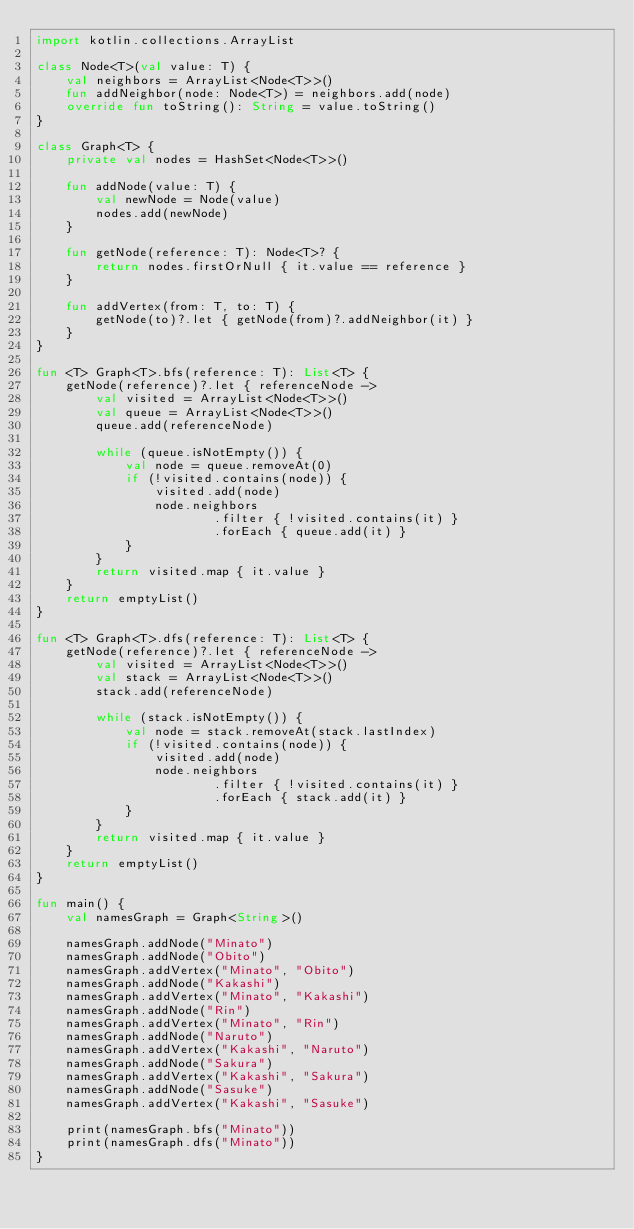<code> <loc_0><loc_0><loc_500><loc_500><_Kotlin_>import kotlin.collections.ArrayList

class Node<T>(val value: T) {
    val neighbors = ArrayList<Node<T>>()
    fun addNeighbor(node: Node<T>) = neighbors.add(node)
    override fun toString(): String = value.toString()
}

class Graph<T> {
    private val nodes = HashSet<Node<T>>()

    fun addNode(value: T) {
        val newNode = Node(value)
        nodes.add(newNode)
    }

    fun getNode(reference: T): Node<T>? {
        return nodes.firstOrNull { it.value == reference }
    }

    fun addVertex(from: T, to: T) {
        getNode(to)?.let { getNode(from)?.addNeighbor(it) }
    }
}

fun <T> Graph<T>.bfs(reference: T): List<T> {
    getNode(reference)?.let { referenceNode ->
        val visited = ArrayList<Node<T>>()
        val queue = ArrayList<Node<T>>()
        queue.add(referenceNode)

        while (queue.isNotEmpty()) {
            val node = queue.removeAt(0)
            if (!visited.contains(node)) {
                visited.add(node)
                node.neighbors
                        .filter { !visited.contains(it) }
                        .forEach { queue.add(it) }
            }
        }
        return visited.map { it.value }
    }
    return emptyList()
}

fun <T> Graph<T>.dfs(reference: T): List<T> {
    getNode(reference)?.let { referenceNode ->
        val visited = ArrayList<Node<T>>()
        val stack = ArrayList<Node<T>>()
        stack.add(referenceNode)

        while (stack.isNotEmpty()) {
            val node = stack.removeAt(stack.lastIndex)
            if (!visited.contains(node)) {
                visited.add(node)
                node.neighbors
                        .filter { !visited.contains(it) }
                        .forEach { stack.add(it) }
            }
        }
        return visited.map { it.value }
    }
    return emptyList()
}

fun main() {
    val namesGraph = Graph<String>()

    namesGraph.addNode("Minato")
    namesGraph.addNode("Obito")
    namesGraph.addVertex("Minato", "Obito")
    namesGraph.addNode("Kakashi")
    namesGraph.addVertex("Minato", "Kakashi")
    namesGraph.addNode("Rin")
    namesGraph.addVertex("Minato", "Rin")
    namesGraph.addNode("Naruto")
    namesGraph.addVertex("Kakashi", "Naruto")
    namesGraph.addNode("Sakura")
    namesGraph.addVertex("Kakashi", "Sakura")
    namesGraph.addNode("Sasuke")
    namesGraph.addVertex("Kakashi", "Sasuke")

    print(namesGraph.bfs("Minato"))
    print(namesGraph.dfs("Minato"))
}
</code> 